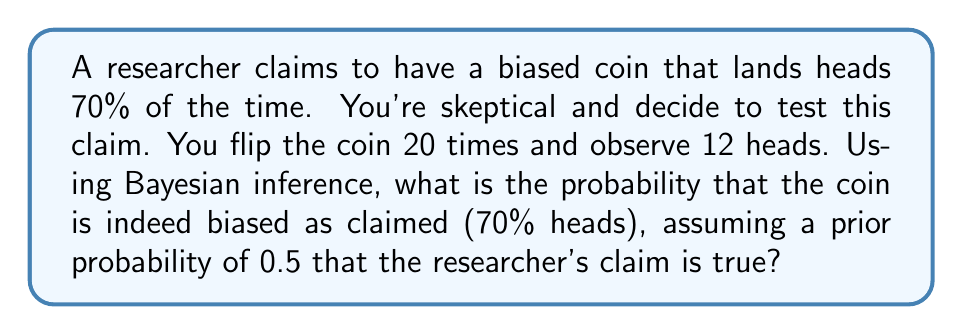Teach me how to tackle this problem. Let's approach this step-by-step using Bayesian inference:

1) Define our hypotheses:
   $H_1$: The coin is biased (70% heads)
   $H_0$: The coin is fair (50% heads)

2) Set up the prior probabilities:
   $P(H_1) = 0.5$ (given in the question)
   $P(H_0) = 1 - P(H_1) = 0.5$

3) Calculate the likelihood of observing 12 heads in 20 flips for each hypothesis:
   For $H_1$: $P(D|H_1) = \binom{20}{12} (0.7)^{12} (0.3)^8$
   For $H_0$: $P(D|H_0) = \binom{20}{12} (0.5)^{20}$

4) Apply Bayes' theorem:
   $$P(H_1|D) = \frac{P(D|H_1)P(H_1)}{P(D|H_1)P(H_1) + P(D|H_0)P(H_0)}$$

5) Calculate the numerator:
   $P(D|H_1)P(H_1) = \binom{20}{12} (0.7)^{12} (0.3)^8 * 0.5 = 0.1236$

6) Calculate the denominator:
   $P(D|H_1)P(H_1) + P(D|H_0)P(H_0)$
   $= 0.1236 + \binom{20}{12} (0.5)^{20} * 0.5$
   $= 0.1236 + 0.0577 = 0.1813$

7) Final calculation:
   $$P(H_1|D) = \frac{0.1236}{0.1813} = 0.6817$$
Answer: $0.6817$ or $68.17\%$ 